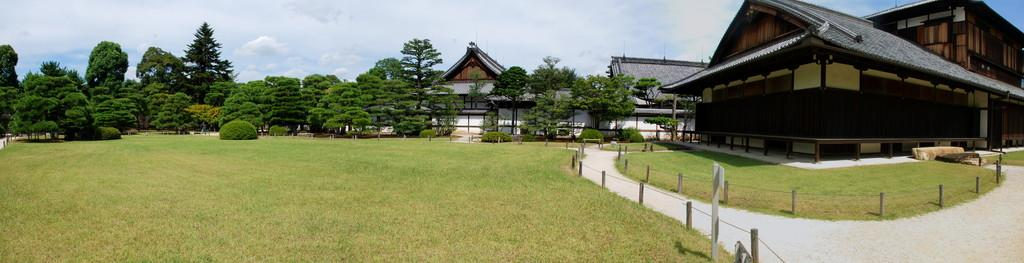What can be seen in the background of the image? The sky is visible in the background of the image. What type of structures are present in the image? There are houses in the image, and rooftops are also visible. What architectural features can be seen in the image? Fences are visible in the image. What is the board used for in the image? The purpose of the board in the image is not specified, but it is present. What is the pole used for in the image? The purpose of the pole in the image is not specified, but it is present. What type of vegetation is in the image? Plants, trees, and grass are present in the image. What is the pathway used for in the image? The pathway in the image is likely used for walking or transportation. How does the daughter interact with the river in the image? There is no river present in the image, so the daughter cannot interact with it. 